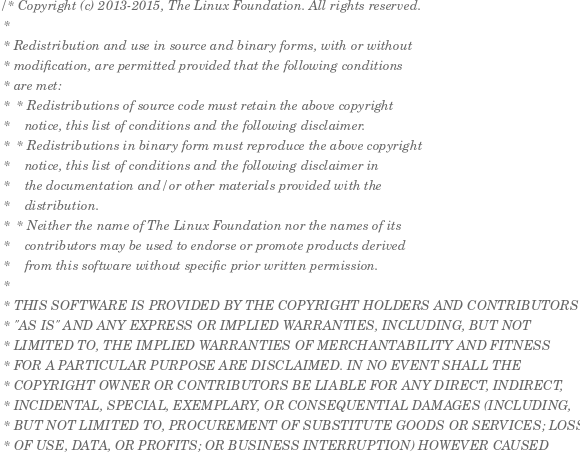<code> <loc_0><loc_0><loc_500><loc_500><_C_>/* Copyright (c) 2013-2015, The Linux Foundation. All rights reserved.
 *
 * Redistribution and use in source and binary forms, with or without
 * modification, are permitted provided that the following conditions
 * are met:
 *  * Redistributions of source code must retain the above copyright
 *    notice, this list of conditions and the following disclaimer.
 *  * Redistributions in binary form must reproduce the above copyright
 *    notice, this list of conditions and the following disclaimer in
 *    the documentation and/or other materials provided with the
 *    distribution.
 *  * Neither the name of The Linux Foundation nor the names of its
 *    contributors may be used to endorse or promote products derived
 *    from this software without specific prior written permission.
 *
 * THIS SOFTWARE IS PROVIDED BY THE COPYRIGHT HOLDERS AND CONTRIBUTORS
 * "AS IS" AND ANY EXPRESS OR IMPLIED WARRANTIES, INCLUDING, BUT NOT
 * LIMITED TO, THE IMPLIED WARRANTIES OF MERCHANTABILITY AND FITNESS
 * FOR A PARTICULAR PURPOSE ARE DISCLAIMED. IN NO EVENT SHALL THE
 * COPYRIGHT OWNER OR CONTRIBUTORS BE LIABLE FOR ANY DIRECT, INDIRECT,
 * INCIDENTAL, SPECIAL, EXEMPLARY, OR CONSEQUENTIAL DAMAGES (INCLUDING,
 * BUT NOT LIMITED TO, PROCUREMENT OF SUBSTITUTE GOODS OR SERVICES; LOSS
 * OF USE, DATA, OR PROFITS; OR BUSINESS INTERRUPTION) HOWEVER CAUSED</code> 